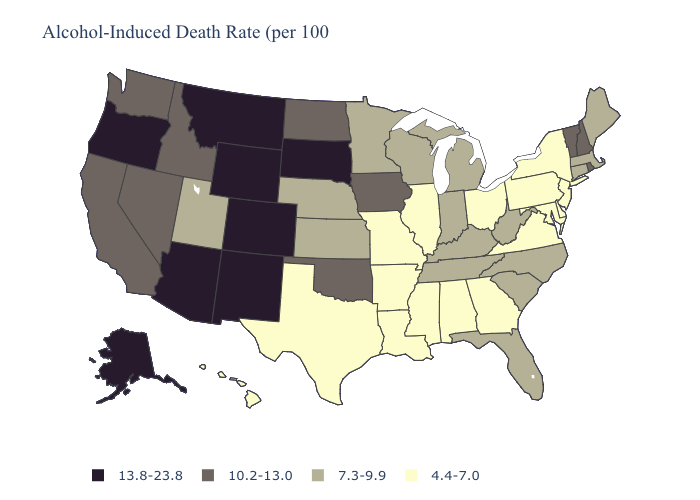Does West Virginia have the lowest value in the South?
Give a very brief answer. No. What is the value of Montana?
Write a very short answer. 13.8-23.8. What is the highest value in states that border Utah?
Be succinct. 13.8-23.8. Does Wisconsin have the same value as Kentucky?
Write a very short answer. Yes. What is the value of Texas?
Keep it brief. 4.4-7.0. Among the states that border Delaware , which have the lowest value?
Keep it brief. Maryland, New Jersey, Pennsylvania. Which states hav the highest value in the South?
Give a very brief answer. Oklahoma. Does West Virginia have the highest value in the USA?
Be succinct. No. Name the states that have a value in the range 10.2-13.0?
Short answer required. California, Idaho, Iowa, Nevada, New Hampshire, North Dakota, Oklahoma, Rhode Island, Vermont, Washington. Does Georgia have the same value as Ohio?
Keep it brief. Yes. What is the value of West Virginia?
Be succinct. 7.3-9.9. What is the highest value in states that border Nebraska?
Short answer required. 13.8-23.8. Which states have the highest value in the USA?
Write a very short answer. Alaska, Arizona, Colorado, Montana, New Mexico, Oregon, South Dakota, Wyoming. Name the states that have a value in the range 10.2-13.0?
Answer briefly. California, Idaho, Iowa, Nevada, New Hampshire, North Dakota, Oklahoma, Rhode Island, Vermont, Washington. 